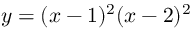Convert formula to latex. <formula><loc_0><loc_0><loc_500><loc_500>y = ( x - 1 ) ^ { 2 } ( x - 2 ) ^ { 2 }</formula> 